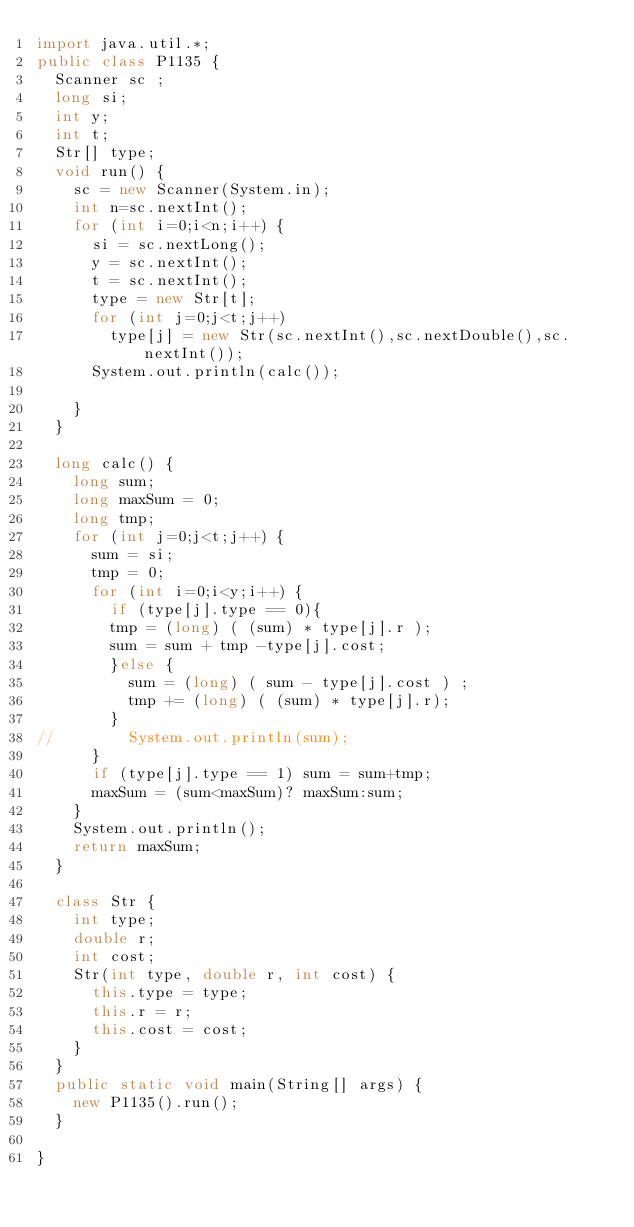Convert code to text. <code><loc_0><loc_0><loc_500><loc_500><_Java_>import java.util.*;
public class P1135 {
	Scanner sc ;
	long si;
	int y;
	int t;
	Str[] type;
	void run() {
		sc = new Scanner(System.in);
		int n=sc.nextInt();
		for (int i=0;i<n;i++) {
			si = sc.nextLong();
			y = sc.nextInt();
			t = sc.nextInt();
			type = new Str[t];
			for (int j=0;j<t;j++) 
				type[j] = new Str(sc.nextInt(),sc.nextDouble(),sc.nextInt());
			System.out.println(calc());
			
		}
	}
	
	long calc() {
		long sum;
		long maxSum = 0;
		long tmp;
		for (int j=0;j<t;j++) {
			sum = si;
			tmp = 0;
			for (int i=0;i<y;i++) {
				if (type[j].type == 0){
				tmp = (long) ( (sum) * type[j].r );
				sum = sum + tmp -type[j].cost;
				}else {
					sum = (long) ( sum - type[j].cost ) ;
					tmp += (long) ( (sum) * type[j].r);
				}
//				System.out.println(sum);
			}
			if (type[j].type == 1) sum = sum+tmp;
			maxSum = (sum<maxSum)? maxSum:sum;
		}
		System.out.println();
		return maxSum;
	}
	
	class Str {
		int type;
		double r;
		int cost;
		Str(int type, double r, int cost) {
			this.type = type;
			this.r = r;
			this.cost = cost;
		}
	}
	public static void main(String[] args) {
		new P1135().run();
	}
	
}</code> 